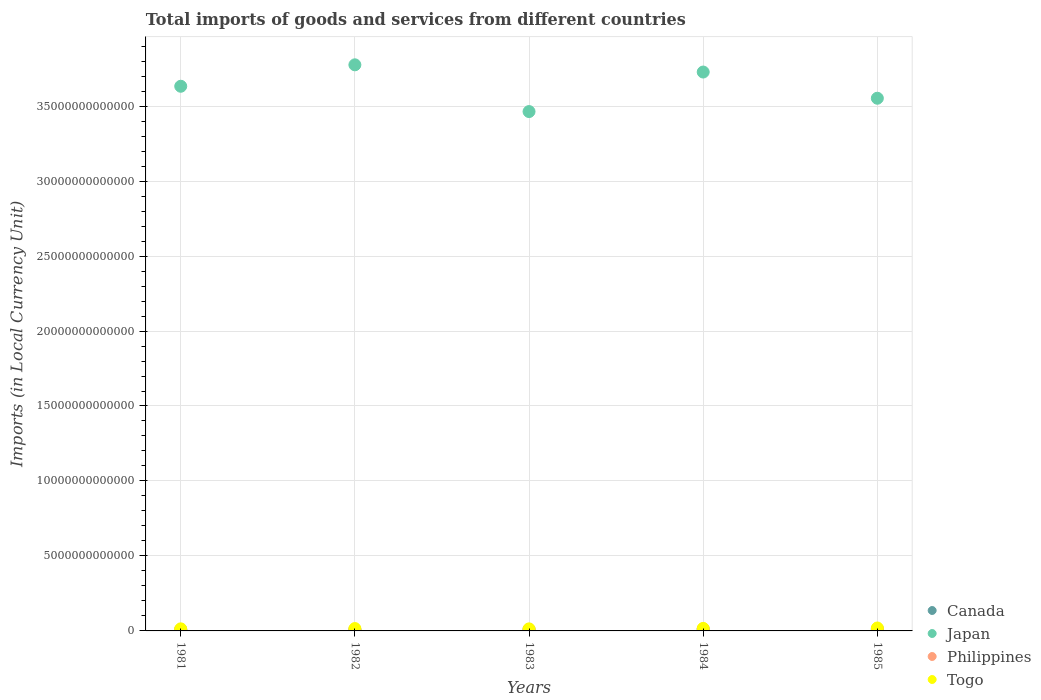What is the Amount of goods and services imports in Philippines in 1984?
Ensure brevity in your answer.  1.32e+11. Across all years, what is the maximum Amount of goods and services imports in Togo?
Offer a terse response. 1.96e+11. Across all years, what is the minimum Amount of goods and services imports in Philippines?
Ensure brevity in your answer.  7.65e+1. In which year was the Amount of goods and services imports in Togo maximum?
Offer a very short reply. 1985. What is the total Amount of goods and services imports in Togo in the graph?
Ensure brevity in your answer.  7.96e+11. What is the difference between the Amount of goods and services imports in Togo in 1981 and that in 1983?
Offer a terse response. 2.10e+09. What is the difference between the Amount of goods and services imports in Japan in 1983 and the Amount of goods and services imports in Philippines in 1981?
Your answer should be very brief. 3.46e+13. What is the average Amount of goods and services imports in Japan per year?
Your answer should be compact. 3.63e+13. In the year 1984, what is the difference between the Amount of goods and services imports in Japan and Amount of goods and services imports in Canada?
Ensure brevity in your answer.  3.72e+13. In how many years, is the Amount of goods and services imports in Philippines greater than 37000000000000 LCU?
Offer a very short reply. 0. What is the ratio of the Amount of goods and services imports in Togo in 1983 to that in 1985?
Make the answer very short. 0.7. Is the Amount of goods and services imports in Japan in 1981 less than that in 1984?
Ensure brevity in your answer.  Yes. Is the difference between the Amount of goods and services imports in Japan in 1983 and 1984 greater than the difference between the Amount of goods and services imports in Canada in 1983 and 1984?
Your answer should be very brief. No. What is the difference between the highest and the second highest Amount of goods and services imports in Philippines?
Make the answer very short. 6.30e+09. What is the difference between the highest and the lowest Amount of goods and services imports in Philippines?
Provide a succinct answer. 5.50e+1. Is the sum of the Amount of goods and services imports in Japan in 1983 and 1985 greater than the maximum Amount of goods and services imports in Canada across all years?
Keep it short and to the point. Yes. Is it the case that in every year, the sum of the Amount of goods and services imports in Philippines and Amount of goods and services imports in Canada  is greater than the Amount of goods and services imports in Japan?
Give a very brief answer. No. Does the Amount of goods and services imports in Philippines monotonically increase over the years?
Offer a very short reply. No. Is the Amount of goods and services imports in Canada strictly less than the Amount of goods and services imports in Japan over the years?
Keep it short and to the point. Yes. How many dotlines are there?
Provide a succinct answer. 4. How many years are there in the graph?
Your response must be concise. 5. What is the difference between two consecutive major ticks on the Y-axis?
Offer a terse response. 5.00e+12. Are the values on the major ticks of Y-axis written in scientific E-notation?
Provide a succinct answer. No. Does the graph contain any zero values?
Your answer should be compact. No. How are the legend labels stacked?
Keep it short and to the point. Vertical. What is the title of the graph?
Keep it short and to the point. Total imports of goods and services from different countries. Does "Curacao" appear as one of the legend labels in the graph?
Your response must be concise. No. What is the label or title of the X-axis?
Keep it short and to the point. Years. What is the label or title of the Y-axis?
Offer a terse response. Imports (in Local Currency Unit). What is the Imports (in Local Currency Unit) in Canada in 1981?
Offer a very short reply. 9.42e+1. What is the Imports (in Local Currency Unit) of Japan in 1981?
Offer a very short reply. 3.63e+13. What is the Imports (in Local Currency Unit) in Philippines in 1981?
Give a very brief answer. 7.65e+1. What is the Imports (in Local Currency Unit) of Togo in 1981?
Keep it short and to the point. 1.38e+11. What is the Imports (in Local Currency Unit) of Canada in 1982?
Give a very brief answer. 8.26e+1. What is the Imports (in Local Currency Unit) in Japan in 1982?
Provide a short and direct response. 3.78e+13. What is the Imports (in Local Currency Unit) of Philippines in 1982?
Your response must be concise. 8.29e+1. What is the Imports (in Local Currency Unit) in Togo in 1982?
Give a very brief answer. 1.58e+11. What is the Imports (in Local Currency Unit) of Canada in 1983?
Offer a very short reply. 9.11e+1. What is the Imports (in Local Currency Unit) in Japan in 1983?
Provide a short and direct response. 3.46e+13. What is the Imports (in Local Currency Unit) of Philippines in 1983?
Provide a succinct answer. 1.04e+11. What is the Imports (in Local Currency Unit) in Togo in 1983?
Ensure brevity in your answer.  1.36e+11. What is the Imports (in Local Currency Unit) of Canada in 1984?
Offer a terse response. 1.13e+11. What is the Imports (in Local Currency Unit) in Japan in 1984?
Provide a short and direct response. 3.73e+13. What is the Imports (in Local Currency Unit) in Philippines in 1984?
Provide a short and direct response. 1.32e+11. What is the Imports (in Local Currency Unit) of Togo in 1984?
Ensure brevity in your answer.  1.67e+11. What is the Imports (in Local Currency Unit) of Canada in 1985?
Give a very brief answer. 1.26e+11. What is the Imports (in Local Currency Unit) in Japan in 1985?
Give a very brief answer. 3.55e+13. What is the Imports (in Local Currency Unit) in Philippines in 1985?
Ensure brevity in your answer.  1.25e+11. What is the Imports (in Local Currency Unit) of Togo in 1985?
Offer a very short reply. 1.96e+11. Across all years, what is the maximum Imports (in Local Currency Unit) in Canada?
Your answer should be compact. 1.26e+11. Across all years, what is the maximum Imports (in Local Currency Unit) of Japan?
Provide a succinct answer. 3.78e+13. Across all years, what is the maximum Imports (in Local Currency Unit) in Philippines?
Keep it short and to the point. 1.32e+11. Across all years, what is the maximum Imports (in Local Currency Unit) in Togo?
Your answer should be very brief. 1.96e+11. Across all years, what is the minimum Imports (in Local Currency Unit) in Canada?
Offer a very short reply. 8.26e+1. Across all years, what is the minimum Imports (in Local Currency Unit) in Japan?
Your answer should be very brief. 3.46e+13. Across all years, what is the minimum Imports (in Local Currency Unit) in Philippines?
Keep it short and to the point. 7.65e+1. Across all years, what is the minimum Imports (in Local Currency Unit) in Togo?
Your answer should be compact. 1.36e+11. What is the total Imports (in Local Currency Unit) of Canada in the graph?
Give a very brief answer. 5.07e+11. What is the total Imports (in Local Currency Unit) in Japan in the graph?
Make the answer very short. 1.82e+14. What is the total Imports (in Local Currency Unit) in Philippines in the graph?
Offer a very short reply. 5.20e+11. What is the total Imports (in Local Currency Unit) in Togo in the graph?
Give a very brief answer. 7.96e+11. What is the difference between the Imports (in Local Currency Unit) in Canada in 1981 and that in 1982?
Offer a terse response. 1.16e+1. What is the difference between the Imports (in Local Currency Unit) of Japan in 1981 and that in 1982?
Your answer should be compact. -1.43e+12. What is the difference between the Imports (in Local Currency Unit) of Philippines in 1981 and that in 1982?
Give a very brief answer. -6.38e+09. What is the difference between the Imports (in Local Currency Unit) of Togo in 1981 and that in 1982?
Ensure brevity in your answer.  -1.99e+1. What is the difference between the Imports (in Local Currency Unit) of Canada in 1981 and that in 1983?
Your answer should be very brief. 3.10e+09. What is the difference between the Imports (in Local Currency Unit) of Japan in 1981 and that in 1983?
Give a very brief answer. 1.69e+12. What is the difference between the Imports (in Local Currency Unit) of Philippines in 1981 and that in 1983?
Your answer should be very brief. -2.71e+1. What is the difference between the Imports (in Local Currency Unit) of Togo in 1981 and that in 1983?
Ensure brevity in your answer.  2.10e+09. What is the difference between the Imports (in Local Currency Unit) of Canada in 1981 and that in 1984?
Make the answer very short. -1.84e+1. What is the difference between the Imports (in Local Currency Unit) of Japan in 1981 and that in 1984?
Your answer should be compact. -9.49e+11. What is the difference between the Imports (in Local Currency Unit) in Philippines in 1981 and that in 1984?
Your answer should be very brief. -5.50e+1. What is the difference between the Imports (in Local Currency Unit) in Togo in 1981 and that in 1984?
Keep it short and to the point. -2.89e+1. What is the difference between the Imports (in Local Currency Unit) of Canada in 1981 and that in 1985?
Provide a short and direct response. -3.16e+1. What is the difference between the Imports (in Local Currency Unit) of Japan in 1981 and that in 1985?
Offer a terse response. 7.99e+11. What is the difference between the Imports (in Local Currency Unit) in Philippines in 1981 and that in 1985?
Make the answer very short. -4.87e+1. What is the difference between the Imports (in Local Currency Unit) of Togo in 1981 and that in 1985?
Give a very brief answer. -5.71e+1. What is the difference between the Imports (in Local Currency Unit) in Canada in 1982 and that in 1983?
Make the answer very short. -8.54e+09. What is the difference between the Imports (in Local Currency Unit) in Japan in 1982 and that in 1983?
Provide a succinct answer. 3.12e+12. What is the difference between the Imports (in Local Currency Unit) in Philippines in 1982 and that in 1983?
Provide a succinct answer. -2.07e+1. What is the difference between the Imports (in Local Currency Unit) in Togo in 1982 and that in 1983?
Keep it short and to the point. 2.20e+1. What is the difference between the Imports (in Local Currency Unit) in Canada in 1982 and that in 1984?
Give a very brief answer. -3.01e+1. What is the difference between the Imports (in Local Currency Unit) of Japan in 1982 and that in 1984?
Make the answer very short. 4.81e+11. What is the difference between the Imports (in Local Currency Unit) in Philippines in 1982 and that in 1984?
Your answer should be compact. -4.86e+1. What is the difference between the Imports (in Local Currency Unit) in Togo in 1982 and that in 1984?
Provide a succinct answer. -9.00e+09. What is the difference between the Imports (in Local Currency Unit) of Canada in 1982 and that in 1985?
Offer a very short reply. -4.32e+1. What is the difference between the Imports (in Local Currency Unit) in Japan in 1982 and that in 1985?
Your answer should be compact. 2.23e+12. What is the difference between the Imports (in Local Currency Unit) of Philippines in 1982 and that in 1985?
Give a very brief answer. -4.23e+1. What is the difference between the Imports (in Local Currency Unit) in Togo in 1982 and that in 1985?
Your answer should be very brief. -3.72e+1. What is the difference between the Imports (in Local Currency Unit) in Canada in 1983 and that in 1984?
Provide a short and direct response. -2.16e+1. What is the difference between the Imports (in Local Currency Unit) of Japan in 1983 and that in 1984?
Ensure brevity in your answer.  -2.64e+12. What is the difference between the Imports (in Local Currency Unit) in Philippines in 1983 and that in 1984?
Ensure brevity in your answer.  -2.79e+1. What is the difference between the Imports (in Local Currency Unit) in Togo in 1983 and that in 1984?
Keep it short and to the point. -3.10e+1. What is the difference between the Imports (in Local Currency Unit) of Canada in 1983 and that in 1985?
Your answer should be compact. -3.47e+1. What is the difference between the Imports (in Local Currency Unit) in Japan in 1983 and that in 1985?
Provide a short and direct response. -8.89e+11. What is the difference between the Imports (in Local Currency Unit) in Philippines in 1983 and that in 1985?
Your answer should be very brief. -2.16e+1. What is the difference between the Imports (in Local Currency Unit) in Togo in 1983 and that in 1985?
Your answer should be compact. -5.92e+1. What is the difference between the Imports (in Local Currency Unit) in Canada in 1984 and that in 1985?
Your answer should be compact. -1.32e+1. What is the difference between the Imports (in Local Currency Unit) in Japan in 1984 and that in 1985?
Give a very brief answer. 1.75e+12. What is the difference between the Imports (in Local Currency Unit) in Philippines in 1984 and that in 1985?
Make the answer very short. 6.30e+09. What is the difference between the Imports (in Local Currency Unit) in Togo in 1984 and that in 1985?
Ensure brevity in your answer.  -2.82e+1. What is the difference between the Imports (in Local Currency Unit) of Canada in 1981 and the Imports (in Local Currency Unit) of Japan in 1982?
Provide a short and direct response. -3.77e+13. What is the difference between the Imports (in Local Currency Unit) in Canada in 1981 and the Imports (in Local Currency Unit) in Philippines in 1982?
Offer a terse response. 1.14e+1. What is the difference between the Imports (in Local Currency Unit) of Canada in 1981 and the Imports (in Local Currency Unit) of Togo in 1982?
Your answer should be very brief. -6.42e+1. What is the difference between the Imports (in Local Currency Unit) of Japan in 1981 and the Imports (in Local Currency Unit) of Philippines in 1982?
Your response must be concise. 3.62e+13. What is the difference between the Imports (in Local Currency Unit) in Japan in 1981 and the Imports (in Local Currency Unit) in Togo in 1982?
Provide a succinct answer. 3.62e+13. What is the difference between the Imports (in Local Currency Unit) of Philippines in 1981 and the Imports (in Local Currency Unit) of Togo in 1982?
Ensure brevity in your answer.  -8.19e+1. What is the difference between the Imports (in Local Currency Unit) in Canada in 1981 and the Imports (in Local Currency Unit) in Japan in 1983?
Your response must be concise. -3.45e+13. What is the difference between the Imports (in Local Currency Unit) of Canada in 1981 and the Imports (in Local Currency Unit) of Philippines in 1983?
Provide a succinct answer. -9.39e+09. What is the difference between the Imports (in Local Currency Unit) in Canada in 1981 and the Imports (in Local Currency Unit) in Togo in 1983?
Ensure brevity in your answer.  -4.22e+1. What is the difference between the Imports (in Local Currency Unit) of Japan in 1981 and the Imports (in Local Currency Unit) of Philippines in 1983?
Keep it short and to the point. 3.62e+13. What is the difference between the Imports (in Local Currency Unit) of Japan in 1981 and the Imports (in Local Currency Unit) of Togo in 1983?
Provide a succinct answer. 3.62e+13. What is the difference between the Imports (in Local Currency Unit) of Philippines in 1981 and the Imports (in Local Currency Unit) of Togo in 1983?
Make the answer very short. -5.99e+1. What is the difference between the Imports (in Local Currency Unit) in Canada in 1981 and the Imports (in Local Currency Unit) in Japan in 1984?
Make the answer very short. -3.72e+13. What is the difference between the Imports (in Local Currency Unit) in Canada in 1981 and the Imports (in Local Currency Unit) in Philippines in 1984?
Ensure brevity in your answer.  -3.73e+1. What is the difference between the Imports (in Local Currency Unit) in Canada in 1981 and the Imports (in Local Currency Unit) in Togo in 1984?
Offer a very short reply. -7.32e+1. What is the difference between the Imports (in Local Currency Unit) in Japan in 1981 and the Imports (in Local Currency Unit) in Philippines in 1984?
Your response must be concise. 3.62e+13. What is the difference between the Imports (in Local Currency Unit) of Japan in 1981 and the Imports (in Local Currency Unit) of Togo in 1984?
Keep it short and to the point. 3.62e+13. What is the difference between the Imports (in Local Currency Unit) of Philippines in 1981 and the Imports (in Local Currency Unit) of Togo in 1984?
Give a very brief answer. -9.09e+1. What is the difference between the Imports (in Local Currency Unit) of Canada in 1981 and the Imports (in Local Currency Unit) of Japan in 1985?
Offer a very short reply. -3.54e+13. What is the difference between the Imports (in Local Currency Unit) of Canada in 1981 and the Imports (in Local Currency Unit) of Philippines in 1985?
Keep it short and to the point. -3.10e+1. What is the difference between the Imports (in Local Currency Unit) in Canada in 1981 and the Imports (in Local Currency Unit) in Togo in 1985?
Give a very brief answer. -1.01e+11. What is the difference between the Imports (in Local Currency Unit) in Japan in 1981 and the Imports (in Local Currency Unit) in Philippines in 1985?
Your answer should be very brief. 3.62e+13. What is the difference between the Imports (in Local Currency Unit) of Japan in 1981 and the Imports (in Local Currency Unit) of Togo in 1985?
Your answer should be compact. 3.61e+13. What is the difference between the Imports (in Local Currency Unit) of Philippines in 1981 and the Imports (in Local Currency Unit) of Togo in 1985?
Your answer should be compact. -1.19e+11. What is the difference between the Imports (in Local Currency Unit) in Canada in 1982 and the Imports (in Local Currency Unit) in Japan in 1983?
Ensure brevity in your answer.  -3.46e+13. What is the difference between the Imports (in Local Currency Unit) in Canada in 1982 and the Imports (in Local Currency Unit) in Philippines in 1983?
Keep it short and to the point. -2.10e+1. What is the difference between the Imports (in Local Currency Unit) of Canada in 1982 and the Imports (in Local Currency Unit) of Togo in 1983?
Make the answer very short. -5.38e+1. What is the difference between the Imports (in Local Currency Unit) of Japan in 1982 and the Imports (in Local Currency Unit) of Philippines in 1983?
Offer a very short reply. 3.76e+13. What is the difference between the Imports (in Local Currency Unit) in Japan in 1982 and the Imports (in Local Currency Unit) in Togo in 1983?
Provide a succinct answer. 3.76e+13. What is the difference between the Imports (in Local Currency Unit) in Philippines in 1982 and the Imports (in Local Currency Unit) in Togo in 1983?
Provide a succinct answer. -5.35e+1. What is the difference between the Imports (in Local Currency Unit) of Canada in 1982 and the Imports (in Local Currency Unit) of Japan in 1984?
Provide a succinct answer. -3.72e+13. What is the difference between the Imports (in Local Currency Unit) of Canada in 1982 and the Imports (in Local Currency Unit) of Philippines in 1984?
Provide a short and direct response. -4.89e+1. What is the difference between the Imports (in Local Currency Unit) of Canada in 1982 and the Imports (in Local Currency Unit) of Togo in 1984?
Your answer should be very brief. -8.48e+1. What is the difference between the Imports (in Local Currency Unit) of Japan in 1982 and the Imports (in Local Currency Unit) of Philippines in 1984?
Offer a very short reply. 3.76e+13. What is the difference between the Imports (in Local Currency Unit) of Japan in 1982 and the Imports (in Local Currency Unit) of Togo in 1984?
Keep it short and to the point. 3.76e+13. What is the difference between the Imports (in Local Currency Unit) of Philippines in 1982 and the Imports (in Local Currency Unit) of Togo in 1984?
Give a very brief answer. -8.45e+1. What is the difference between the Imports (in Local Currency Unit) of Canada in 1982 and the Imports (in Local Currency Unit) of Japan in 1985?
Your answer should be very brief. -3.54e+13. What is the difference between the Imports (in Local Currency Unit) of Canada in 1982 and the Imports (in Local Currency Unit) of Philippines in 1985?
Make the answer very short. -4.26e+1. What is the difference between the Imports (in Local Currency Unit) in Canada in 1982 and the Imports (in Local Currency Unit) in Togo in 1985?
Make the answer very short. -1.13e+11. What is the difference between the Imports (in Local Currency Unit) of Japan in 1982 and the Imports (in Local Currency Unit) of Philippines in 1985?
Make the answer very short. 3.76e+13. What is the difference between the Imports (in Local Currency Unit) in Japan in 1982 and the Imports (in Local Currency Unit) in Togo in 1985?
Make the answer very short. 3.76e+13. What is the difference between the Imports (in Local Currency Unit) in Philippines in 1982 and the Imports (in Local Currency Unit) in Togo in 1985?
Provide a succinct answer. -1.13e+11. What is the difference between the Imports (in Local Currency Unit) of Canada in 1983 and the Imports (in Local Currency Unit) of Japan in 1984?
Your response must be concise. -3.72e+13. What is the difference between the Imports (in Local Currency Unit) in Canada in 1983 and the Imports (in Local Currency Unit) in Philippines in 1984?
Make the answer very short. -4.04e+1. What is the difference between the Imports (in Local Currency Unit) in Canada in 1983 and the Imports (in Local Currency Unit) in Togo in 1984?
Keep it short and to the point. -7.63e+1. What is the difference between the Imports (in Local Currency Unit) of Japan in 1983 and the Imports (in Local Currency Unit) of Philippines in 1984?
Your answer should be very brief. 3.45e+13. What is the difference between the Imports (in Local Currency Unit) in Japan in 1983 and the Imports (in Local Currency Unit) in Togo in 1984?
Your answer should be very brief. 3.45e+13. What is the difference between the Imports (in Local Currency Unit) in Philippines in 1983 and the Imports (in Local Currency Unit) in Togo in 1984?
Give a very brief answer. -6.38e+1. What is the difference between the Imports (in Local Currency Unit) of Canada in 1983 and the Imports (in Local Currency Unit) of Japan in 1985?
Provide a short and direct response. -3.54e+13. What is the difference between the Imports (in Local Currency Unit) of Canada in 1983 and the Imports (in Local Currency Unit) of Philippines in 1985?
Provide a short and direct response. -3.41e+1. What is the difference between the Imports (in Local Currency Unit) of Canada in 1983 and the Imports (in Local Currency Unit) of Togo in 1985?
Keep it short and to the point. -1.04e+11. What is the difference between the Imports (in Local Currency Unit) of Japan in 1983 and the Imports (in Local Currency Unit) of Philippines in 1985?
Your response must be concise. 3.45e+13. What is the difference between the Imports (in Local Currency Unit) in Japan in 1983 and the Imports (in Local Currency Unit) in Togo in 1985?
Offer a very short reply. 3.44e+13. What is the difference between the Imports (in Local Currency Unit) in Philippines in 1983 and the Imports (in Local Currency Unit) in Togo in 1985?
Offer a terse response. -9.20e+1. What is the difference between the Imports (in Local Currency Unit) in Canada in 1984 and the Imports (in Local Currency Unit) in Japan in 1985?
Provide a short and direct response. -3.54e+13. What is the difference between the Imports (in Local Currency Unit) in Canada in 1984 and the Imports (in Local Currency Unit) in Philippines in 1985?
Your answer should be very brief. -1.25e+1. What is the difference between the Imports (in Local Currency Unit) of Canada in 1984 and the Imports (in Local Currency Unit) of Togo in 1985?
Provide a succinct answer. -8.29e+1. What is the difference between the Imports (in Local Currency Unit) of Japan in 1984 and the Imports (in Local Currency Unit) of Philippines in 1985?
Your answer should be very brief. 3.71e+13. What is the difference between the Imports (in Local Currency Unit) of Japan in 1984 and the Imports (in Local Currency Unit) of Togo in 1985?
Keep it short and to the point. 3.71e+13. What is the difference between the Imports (in Local Currency Unit) of Philippines in 1984 and the Imports (in Local Currency Unit) of Togo in 1985?
Ensure brevity in your answer.  -6.41e+1. What is the average Imports (in Local Currency Unit) of Canada per year?
Ensure brevity in your answer.  1.01e+11. What is the average Imports (in Local Currency Unit) of Japan per year?
Give a very brief answer. 3.63e+13. What is the average Imports (in Local Currency Unit) of Philippines per year?
Offer a very short reply. 1.04e+11. What is the average Imports (in Local Currency Unit) of Togo per year?
Provide a succinct answer. 1.59e+11. In the year 1981, what is the difference between the Imports (in Local Currency Unit) in Canada and Imports (in Local Currency Unit) in Japan?
Offer a terse response. -3.62e+13. In the year 1981, what is the difference between the Imports (in Local Currency Unit) in Canada and Imports (in Local Currency Unit) in Philippines?
Ensure brevity in your answer.  1.77e+1. In the year 1981, what is the difference between the Imports (in Local Currency Unit) in Canada and Imports (in Local Currency Unit) in Togo?
Offer a very short reply. -4.43e+1. In the year 1981, what is the difference between the Imports (in Local Currency Unit) in Japan and Imports (in Local Currency Unit) in Philippines?
Your response must be concise. 3.62e+13. In the year 1981, what is the difference between the Imports (in Local Currency Unit) of Japan and Imports (in Local Currency Unit) of Togo?
Your answer should be very brief. 3.62e+13. In the year 1981, what is the difference between the Imports (in Local Currency Unit) of Philippines and Imports (in Local Currency Unit) of Togo?
Ensure brevity in your answer.  -6.20e+1. In the year 1982, what is the difference between the Imports (in Local Currency Unit) of Canada and Imports (in Local Currency Unit) of Japan?
Provide a short and direct response. -3.77e+13. In the year 1982, what is the difference between the Imports (in Local Currency Unit) of Canada and Imports (in Local Currency Unit) of Philippines?
Provide a succinct answer. -2.87e+08. In the year 1982, what is the difference between the Imports (in Local Currency Unit) in Canada and Imports (in Local Currency Unit) in Togo?
Keep it short and to the point. -7.58e+1. In the year 1982, what is the difference between the Imports (in Local Currency Unit) in Japan and Imports (in Local Currency Unit) in Philippines?
Your answer should be very brief. 3.77e+13. In the year 1982, what is the difference between the Imports (in Local Currency Unit) of Japan and Imports (in Local Currency Unit) of Togo?
Keep it short and to the point. 3.76e+13. In the year 1982, what is the difference between the Imports (in Local Currency Unit) of Philippines and Imports (in Local Currency Unit) of Togo?
Your answer should be very brief. -7.55e+1. In the year 1983, what is the difference between the Imports (in Local Currency Unit) in Canada and Imports (in Local Currency Unit) in Japan?
Offer a very short reply. -3.45e+13. In the year 1983, what is the difference between the Imports (in Local Currency Unit) in Canada and Imports (in Local Currency Unit) in Philippines?
Give a very brief answer. -1.25e+1. In the year 1983, what is the difference between the Imports (in Local Currency Unit) of Canada and Imports (in Local Currency Unit) of Togo?
Give a very brief answer. -4.53e+1. In the year 1983, what is the difference between the Imports (in Local Currency Unit) of Japan and Imports (in Local Currency Unit) of Philippines?
Offer a terse response. 3.45e+13. In the year 1983, what is the difference between the Imports (in Local Currency Unit) of Japan and Imports (in Local Currency Unit) of Togo?
Ensure brevity in your answer.  3.45e+13. In the year 1983, what is the difference between the Imports (in Local Currency Unit) of Philippines and Imports (in Local Currency Unit) of Togo?
Give a very brief answer. -3.28e+1. In the year 1984, what is the difference between the Imports (in Local Currency Unit) of Canada and Imports (in Local Currency Unit) of Japan?
Give a very brief answer. -3.72e+13. In the year 1984, what is the difference between the Imports (in Local Currency Unit) of Canada and Imports (in Local Currency Unit) of Philippines?
Give a very brief answer. -1.88e+1. In the year 1984, what is the difference between the Imports (in Local Currency Unit) of Canada and Imports (in Local Currency Unit) of Togo?
Ensure brevity in your answer.  -5.47e+1. In the year 1984, what is the difference between the Imports (in Local Currency Unit) of Japan and Imports (in Local Currency Unit) of Philippines?
Your answer should be very brief. 3.71e+13. In the year 1984, what is the difference between the Imports (in Local Currency Unit) of Japan and Imports (in Local Currency Unit) of Togo?
Keep it short and to the point. 3.71e+13. In the year 1984, what is the difference between the Imports (in Local Currency Unit) of Philippines and Imports (in Local Currency Unit) of Togo?
Offer a terse response. -3.59e+1. In the year 1985, what is the difference between the Imports (in Local Currency Unit) of Canada and Imports (in Local Currency Unit) of Japan?
Your answer should be very brief. -3.54e+13. In the year 1985, what is the difference between the Imports (in Local Currency Unit) of Canada and Imports (in Local Currency Unit) of Philippines?
Provide a succinct answer. 6.50e+08. In the year 1985, what is the difference between the Imports (in Local Currency Unit) in Canada and Imports (in Local Currency Unit) in Togo?
Offer a very short reply. -6.97e+1. In the year 1985, what is the difference between the Imports (in Local Currency Unit) in Japan and Imports (in Local Currency Unit) in Philippines?
Your answer should be very brief. 3.54e+13. In the year 1985, what is the difference between the Imports (in Local Currency Unit) in Japan and Imports (in Local Currency Unit) in Togo?
Provide a succinct answer. 3.53e+13. In the year 1985, what is the difference between the Imports (in Local Currency Unit) in Philippines and Imports (in Local Currency Unit) in Togo?
Provide a succinct answer. -7.04e+1. What is the ratio of the Imports (in Local Currency Unit) of Canada in 1981 to that in 1982?
Your answer should be very brief. 1.14. What is the ratio of the Imports (in Local Currency Unit) of Japan in 1981 to that in 1982?
Your answer should be very brief. 0.96. What is the ratio of the Imports (in Local Currency Unit) of Philippines in 1981 to that in 1982?
Offer a terse response. 0.92. What is the ratio of the Imports (in Local Currency Unit) in Togo in 1981 to that in 1982?
Provide a succinct answer. 0.87. What is the ratio of the Imports (in Local Currency Unit) of Canada in 1981 to that in 1983?
Make the answer very short. 1.03. What is the ratio of the Imports (in Local Currency Unit) in Japan in 1981 to that in 1983?
Provide a succinct answer. 1.05. What is the ratio of the Imports (in Local Currency Unit) in Philippines in 1981 to that in 1983?
Ensure brevity in your answer.  0.74. What is the ratio of the Imports (in Local Currency Unit) in Togo in 1981 to that in 1983?
Your answer should be compact. 1.02. What is the ratio of the Imports (in Local Currency Unit) in Canada in 1981 to that in 1984?
Offer a terse response. 0.84. What is the ratio of the Imports (in Local Currency Unit) in Japan in 1981 to that in 1984?
Give a very brief answer. 0.97. What is the ratio of the Imports (in Local Currency Unit) of Philippines in 1981 to that in 1984?
Keep it short and to the point. 0.58. What is the ratio of the Imports (in Local Currency Unit) in Togo in 1981 to that in 1984?
Offer a terse response. 0.83. What is the ratio of the Imports (in Local Currency Unit) of Canada in 1981 to that in 1985?
Provide a short and direct response. 0.75. What is the ratio of the Imports (in Local Currency Unit) of Japan in 1981 to that in 1985?
Give a very brief answer. 1.02. What is the ratio of the Imports (in Local Currency Unit) in Philippines in 1981 to that in 1985?
Your answer should be very brief. 0.61. What is the ratio of the Imports (in Local Currency Unit) in Togo in 1981 to that in 1985?
Your answer should be very brief. 0.71. What is the ratio of the Imports (in Local Currency Unit) in Canada in 1982 to that in 1983?
Your answer should be very brief. 0.91. What is the ratio of the Imports (in Local Currency Unit) of Japan in 1982 to that in 1983?
Your answer should be very brief. 1.09. What is the ratio of the Imports (in Local Currency Unit) of Philippines in 1982 to that in 1983?
Offer a terse response. 0.8. What is the ratio of the Imports (in Local Currency Unit) of Togo in 1982 to that in 1983?
Give a very brief answer. 1.16. What is the ratio of the Imports (in Local Currency Unit) of Canada in 1982 to that in 1984?
Ensure brevity in your answer.  0.73. What is the ratio of the Imports (in Local Currency Unit) in Japan in 1982 to that in 1984?
Offer a terse response. 1.01. What is the ratio of the Imports (in Local Currency Unit) in Philippines in 1982 to that in 1984?
Offer a terse response. 0.63. What is the ratio of the Imports (in Local Currency Unit) of Togo in 1982 to that in 1984?
Give a very brief answer. 0.95. What is the ratio of the Imports (in Local Currency Unit) of Canada in 1982 to that in 1985?
Offer a very short reply. 0.66. What is the ratio of the Imports (in Local Currency Unit) of Japan in 1982 to that in 1985?
Keep it short and to the point. 1.06. What is the ratio of the Imports (in Local Currency Unit) in Philippines in 1982 to that in 1985?
Offer a very short reply. 0.66. What is the ratio of the Imports (in Local Currency Unit) of Togo in 1982 to that in 1985?
Offer a very short reply. 0.81. What is the ratio of the Imports (in Local Currency Unit) of Canada in 1983 to that in 1984?
Provide a succinct answer. 0.81. What is the ratio of the Imports (in Local Currency Unit) of Japan in 1983 to that in 1984?
Ensure brevity in your answer.  0.93. What is the ratio of the Imports (in Local Currency Unit) of Philippines in 1983 to that in 1984?
Keep it short and to the point. 0.79. What is the ratio of the Imports (in Local Currency Unit) of Togo in 1983 to that in 1984?
Your answer should be compact. 0.81. What is the ratio of the Imports (in Local Currency Unit) in Canada in 1983 to that in 1985?
Offer a terse response. 0.72. What is the ratio of the Imports (in Local Currency Unit) in Philippines in 1983 to that in 1985?
Ensure brevity in your answer.  0.83. What is the ratio of the Imports (in Local Currency Unit) of Togo in 1983 to that in 1985?
Give a very brief answer. 0.7. What is the ratio of the Imports (in Local Currency Unit) of Canada in 1984 to that in 1985?
Ensure brevity in your answer.  0.9. What is the ratio of the Imports (in Local Currency Unit) of Japan in 1984 to that in 1985?
Make the answer very short. 1.05. What is the ratio of the Imports (in Local Currency Unit) of Philippines in 1984 to that in 1985?
Keep it short and to the point. 1.05. What is the ratio of the Imports (in Local Currency Unit) of Togo in 1984 to that in 1985?
Provide a short and direct response. 0.86. What is the difference between the highest and the second highest Imports (in Local Currency Unit) of Canada?
Your response must be concise. 1.32e+1. What is the difference between the highest and the second highest Imports (in Local Currency Unit) of Japan?
Offer a very short reply. 4.81e+11. What is the difference between the highest and the second highest Imports (in Local Currency Unit) of Philippines?
Offer a terse response. 6.30e+09. What is the difference between the highest and the second highest Imports (in Local Currency Unit) in Togo?
Your answer should be very brief. 2.82e+1. What is the difference between the highest and the lowest Imports (in Local Currency Unit) in Canada?
Your answer should be very brief. 4.32e+1. What is the difference between the highest and the lowest Imports (in Local Currency Unit) of Japan?
Your response must be concise. 3.12e+12. What is the difference between the highest and the lowest Imports (in Local Currency Unit) in Philippines?
Provide a succinct answer. 5.50e+1. What is the difference between the highest and the lowest Imports (in Local Currency Unit) in Togo?
Give a very brief answer. 5.92e+1. 